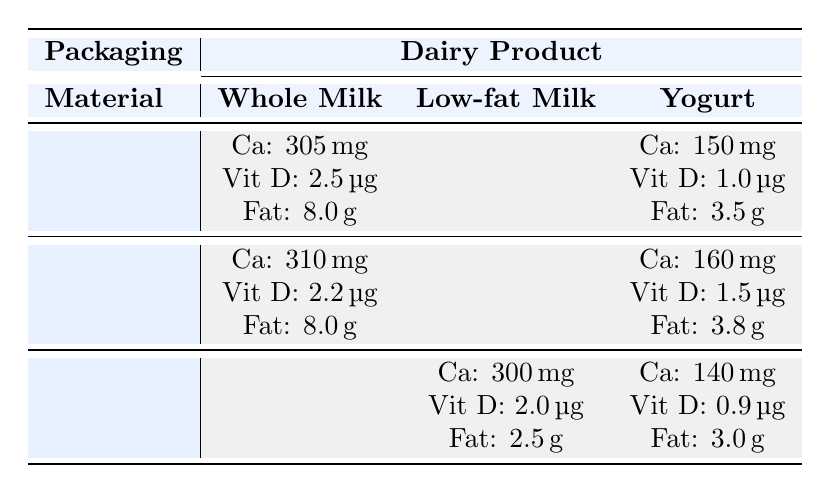What is the calcium content in whole milk packaged in plastic? The table shows that the calcium content in whole milk packaged in plastic is listed as 305 mg.
Answer: 305 mg Which packaging material provides the highest calcium content for yogurt? By comparing the calcium content values for yogurt: Plastic (150 mg), Glass (160 mg), and Tetra Pak (140 mg), it is evident that glass packaging provides the highest calcium content at 160 mg.
Answer: Glass: 160 mg What is the difference in fat content between whole milk in glass and low-fat milk in Tetra Pak? Whole milk in glass has a fat content of 8.0 grams and low-fat milk in Tetra Pak has a fat content of 2.5 grams. The difference is calculated as 8.0 - 2.5 = 5.5 grams.
Answer: 5.5 grams Is the vitamin D content higher in yogurt packaged in plastic or yogurt packaged in glass? The vitamin D content for yogurt in plastic is 1.0 µg and for yogurt in glass is 1.5 µg. Since 1.5 µg is greater than 1.0 µg, the vitamin D content is higher in yogurt packaged in glass.
Answer: Yes, it is higher in glass What is the average vitamin D content for the three types of yogurt packaging? The vitamin D contents for yogurt are: Plastic (1.0 µg), Glass (1.5 µg), and Tetra Pak (0.9 µg). The average is (1.0 + 1.5 + 0.9) / 3 = 1.133 µg.
Answer: 1.133 µg 